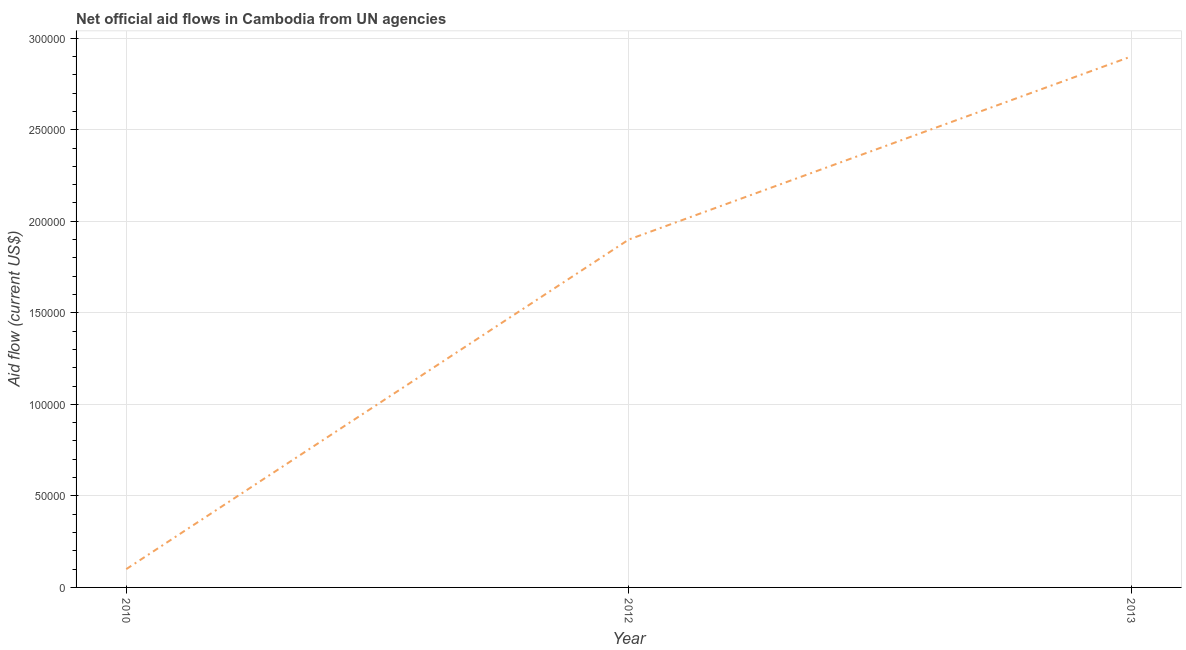What is the net official flows from un agencies in 2010?
Your answer should be very brief. 10000. Across all years, what is the maximum net official flows from un agencies?
Your answer should be very brief. 2.90e+05. Across all years, what is the minimum net official flows from un agencies?
Ensure brevity in your answer.  10000. In which year was the net official flows from un agencies maximum?
Provide a succinct answer. 2013. In which year was the net official flows from un agencies minimum?
Offer a terse response. 2010. What is the sum of the net official flows from un agencies?
Make the answer very short. 4.90e+05. What is the difference between the net official flows from un agencies in 2010 and 2013?
Make the answer very short. -2.80e+05. What is the average net official flows from un agencies per year?
Your answer should be compact. 1.63e+05. In how many years, is the net official flows from un agencies greater than 210000 US$?
Keep it short and to the point. 1. What is the ratio of the net official flows from un agencies in 2010 to that in 2012?
Make the answer very short. 0.05. Is the sum of the net official flows from un agencies in 2010 and 2013 greater than the maximum net official flows from un agencies across all years?
Your answer should be compact. Yes. What is the difference between the highest and the lowest net official flows from un agencies?
Your answer should be compact. 2.80e+05. Does the net official flows from un agencies monotonically increase over the years?
Offer a very short reply. Yes. What is the difference between two consecutive major ticks on the Y-axis?
Provide a short and direct response. 5.00e+04. Are the values on the major ticks of Y-axis written in scientific E-notation?
Your response must be concise. No. What is the title of the graph?
Your answer should be very brief. Net official aid flows in Cambodia from UN agencies. What is the label or title of the X-axis?
Make the answer very short. Year. What is the label or title of the Y-axis?
Give a very brief answer. Aid flow (current US$). What is the Aid flow (current US$) in 2010?
Give a very brief answer. 10000. What is the difference between the Aid flow (current US$) in 2010 and 2013?
Provide a short and direct response. -2.80e+05. What is the ratio of the Aid flow (current US$) in 2010 to that in 2012?
Make the answer very short. 0.05. What is the ratio of the Aid flow (current US$) in 2010 to that in 2013?
Your answer should be very brief. 0.03. What is the ratio of the Aid flow (current US$) in 2012 to that in 2013?
Provide a short and direct response. 0.66. 